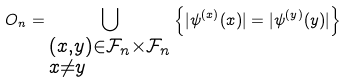Convert formula to latex. <formula><loc_0><loc_0><loc_500><loc_500>O _ { n } = \bigcup _ { \begin{subarray} { c } ( x , y ) \in \mathcal { F } _ { n } \times \mathcal { F } _ { n } \\ x \neq y \end{subarray} } \left \{ | \psi ^ { ( x ) } ( x ) | = | \psi ^ { ( y ) } ( y ) | \right \}</formula> 